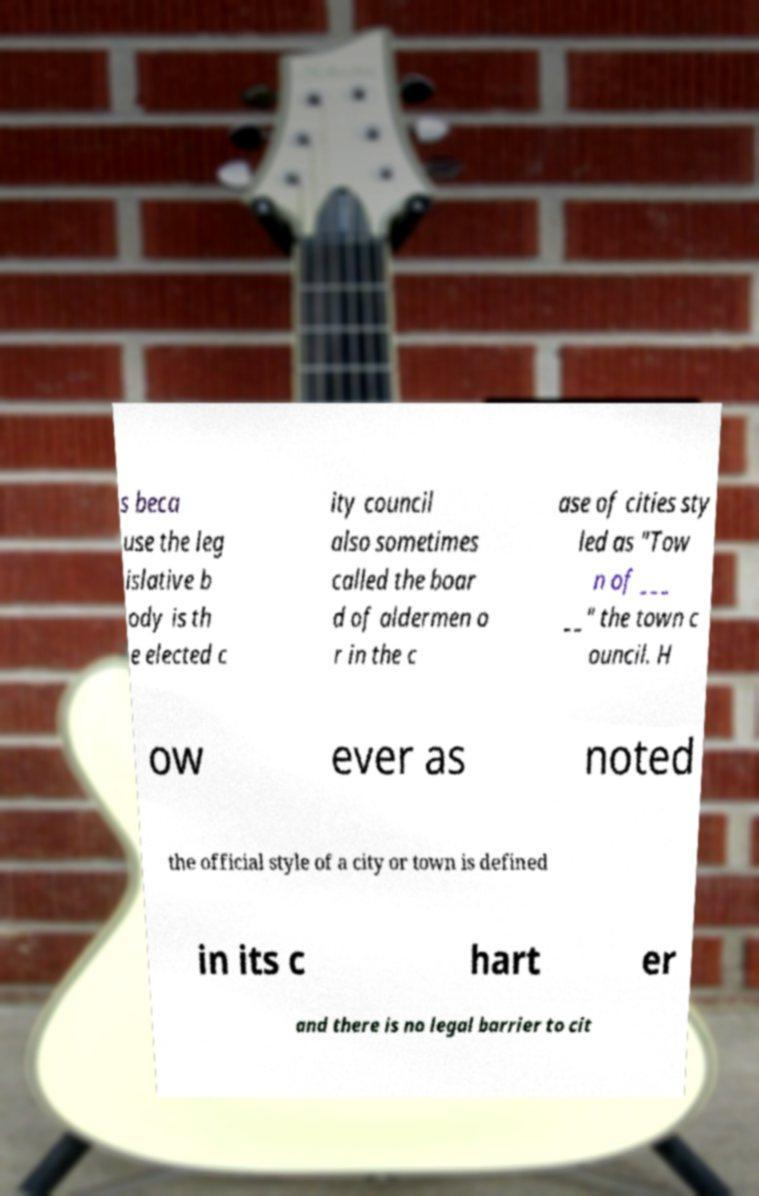I need the written content from this picture converted into text. Can you do that? s beca use the leg islative b ody is th e elected c ity council also sometimes called the boar d of aldermen o r in the c ase of cities sty led as "Tow n of ___ __" the town c ouncil. H ow ever as noted the official style of a city or town is defined in its c hart er and there is no legal barrier to cit 